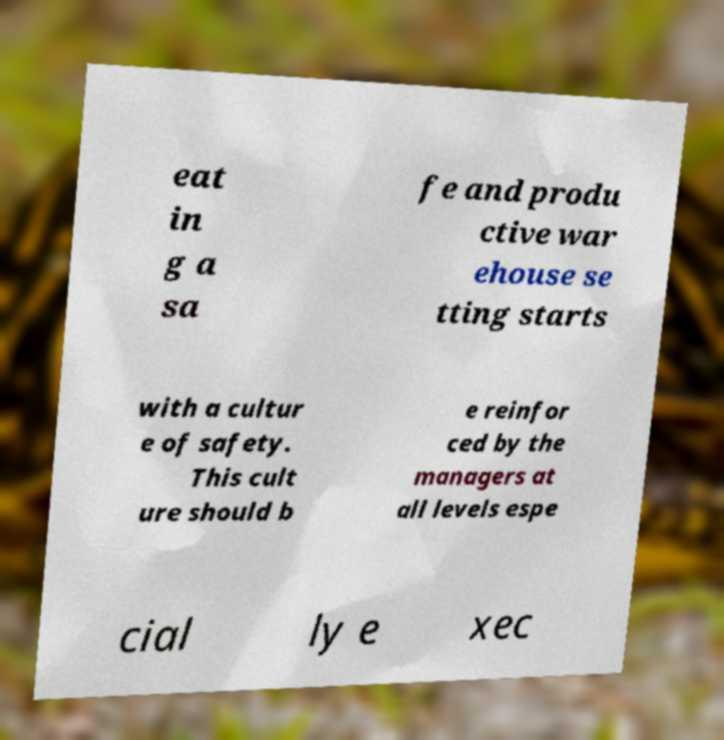Can you accurately transcribe the text from the provided image for me? eat in g a sa fe and produ ctive war ehouse se tting starts with a cultur e of safety. This cult ure should b e reinfor ced by the managers at all levels espe cial ly e xec 